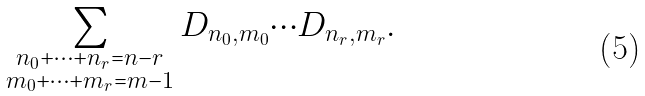Convert formula to latex. <formula><loc_0><loc_0><loc_500><loc_500>\sum _ { \substack { n _ { 0 } + \cdots + n _ { r } = n - r \\ m _ { 0 } + \cdots + m _ { r } = m - 1 } } D _ { n _ { 0 } , m _ { 0 } } \cdots D _ { n _ { r } , m _ { r } } .</formula> 